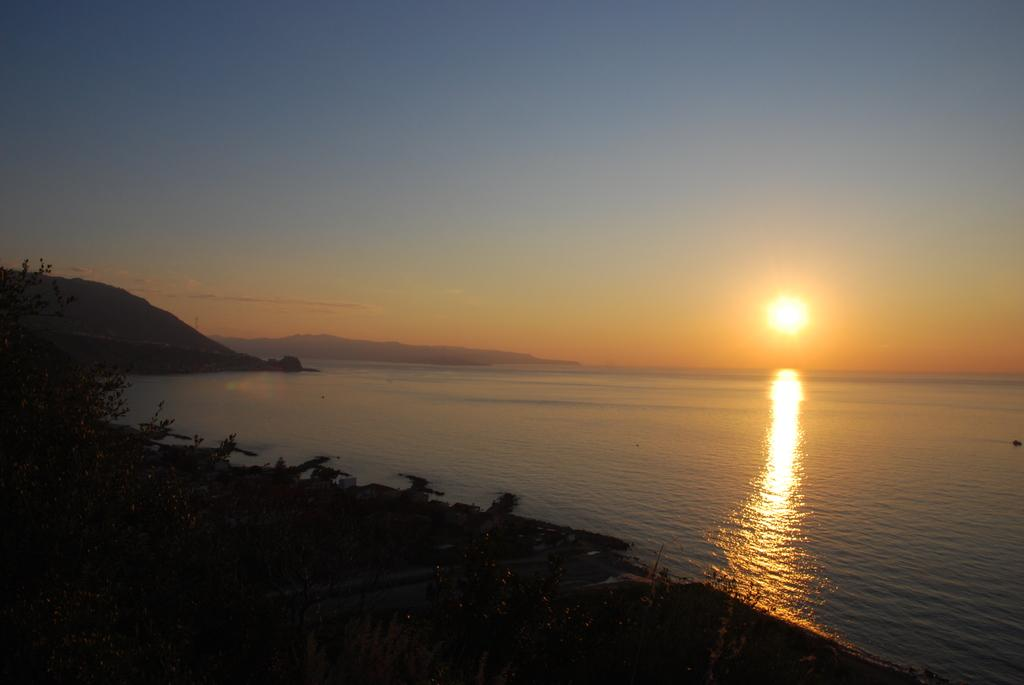What is the main feature in the center of the image? There is water in the center of the image. What type of vegetation can be seen at the bottom of the image? There are trees at the bottom of the image. What type of landscape feature is visible in the background of the image? There are hills in the background of the image. What is visible in the sky in the background of the image? The sky is visible in the background of the image, and the sun is observable. What type of prose is being recited by the guide in the image? There is no guide or prose present in the image; it features water, trees, hills, sky, and the sun. 